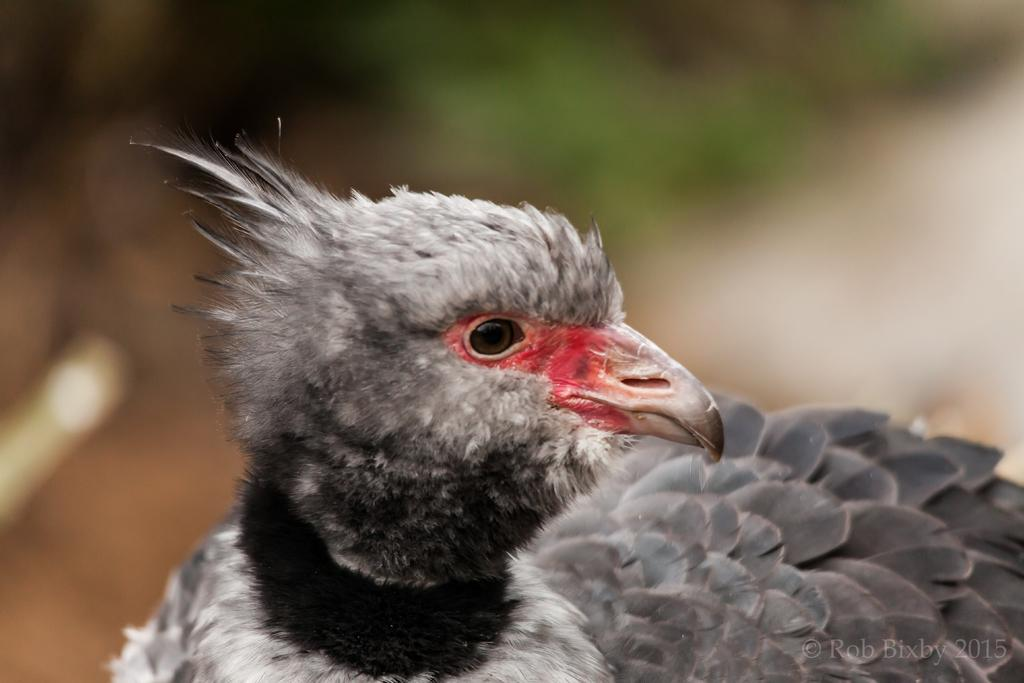What type of animal is present in the image? There is a bird in the image. Can you describe the background of the image? The background of the image is blurred. What type of party is happening in the background of the image? There is no party present in the image; the background is blurred. How many horses can be seen in the image? There are no horses present in the image; it features a bird. 